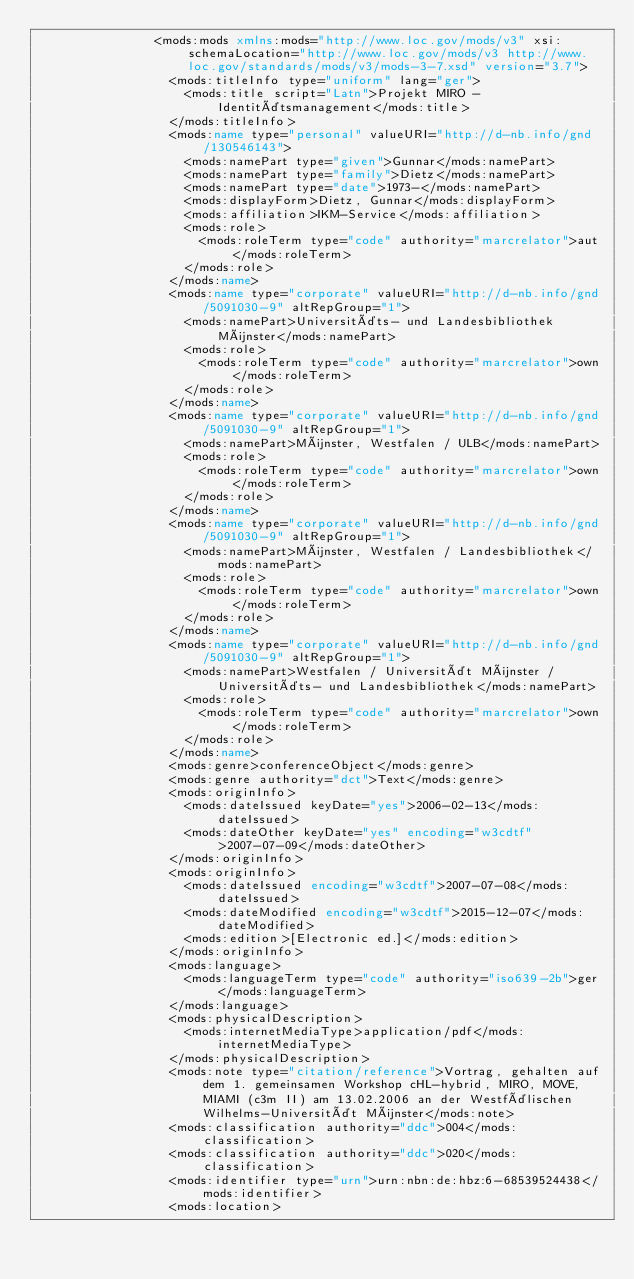<code> <loc_0><loc_0><loc_500><loc_500><_XML_>                <mods:mods xmlns:mods="http://www.loc.gov/mods/v3" xsi:schemaLocation="http://www.loc.gov/mods/v3 http://www.loc.gov/standards/mods/v3/mods-3-7.xsd" version="3.7">
                  <mods:titleInfo type="uniform" lang="ger">
                    <mods:title script="Latn">Projekt MIRO - Identitätsmanagement</mods:title>
                  </mods:titleInfo>
                  <mods:name type="personal" valueURI="http://d-nb.info/gnd/130546143">
                    <mods:namePart type="given">Gunnar</mods:namePart>
                    <mods:namePart type="family">Dietz</mods:namePart>
                    <mods:namePart type="date">1973-</mods:namePart>
                    <mods:displayForm>Dietz, Gunnar</mods:displayForm>
                    <mods:affiliation>IKM-Service</mods:affiliation>
                    <mods:role>
                      <mods:roleTerm type="code" authority="marcrelator">aut</mods:roleTerm>
                    </mods:role>
                  </mods:name>
                  <mods:name type="corporate" valueURI="http://d-nb.info/gnd/5091030-9" altRepGroup="1">
                    <mods:namePart>Universitäts- und Landesbibliothek Münster</mods:namePart>
                    <mods:role>
                      <mods:roleTerm type="code" authority="marcrelator">own</mods:roleTerm>
                    </mods:role>
                  </mods:name>
                  <mods:name type="corporate" valueURI="http://d-nb.info/gnd/5091030-9" altRepGroup="1">
                    <mods:namePart>Münster, Westfalen / ULB</mods:namePart>
                    <mods:role>
                      <mods:roleTerm type="code" authority="marcrelator">own</mods:roleTerm>
                    </mods:role>
                  </mods:name>
                  <mods:name type="corporate" valueURI="http://d-nb.info/gnd/5091030-9" altRepGroup="1">
                    <mods:namePart>Münster, Westfalen / Landesbibliothek</mods:namePart>
                    <mods:role>
                      <mods:roleTerm type="code" authority="marcrelator">own</mods:roleTerm>
                    </mods:role>
                  </mods:name>
                  <mods:name type="corporate" valueURI="http://d-nb.info/gnd/5091030-9" altRepGroup="1">
                    <mods:namePart>Westfalen / Universität Münster / Universitäts- und Landesbibliothek</mods:namePart>
                    <mods:role>
                      <mods:roleTerm type="code" authority="marcrelator">own</mods:roleTerm>
                    </mods:role>
                  </mods:name>
                  <mods:genre>conferenceObject</mods:genre>
                  <mods:genre authority="dct">Text</mods:genre>
                  <mods:originInfo>
                    <mods:dateIssued keyDate="yes">2006-02-13</mods:dateIssued>
                    <mods:dateOther keyDate="yes" encoding="w3cdtf">2007-07-09</mods:dateOther>
                  </mods:originInfo>
                  <mods:originInfo>
                    <mods:dateIssued encoding="w3cdtf">2007-07-08</mods:dateIssued>
                    <mods:dateModified encoding="w3cdtf">2015-12-07</mods:dateModified>
                    <mods:edition>[Electronic ed.]</mods:edition>
                  </mods:originInfo>
                  <mods:language>
                    <mods:languageTerm type="code" authority="iso639-2b">ger</mods:languageTerm>
                  </mods:language>
                  <mods:physicalDescription>
                    <mods:internetMediaType>application/pdf</mods:internetMediaType>
                  </mods:physicalDescription>
                  <mods:note type="citation/reference">Vortrag, gehalten auf dem 1. gemeinsamen Workshop cHL-hybrid, MIRO, MOVE, MIAMI (c3m II) am 13.02.2006 an der Westfälischen Wilhelms-Universität Münster</mods:note>
                  <mods:classification authority="ddc">004</mods:classification>
                  <mods:classification authority="ddc">020</mods:classification>
                  <mods:identifier type="urn">urn:nbn:de:hbz:6-68539524438</mods:identifier>
                  <mods:location></code> 